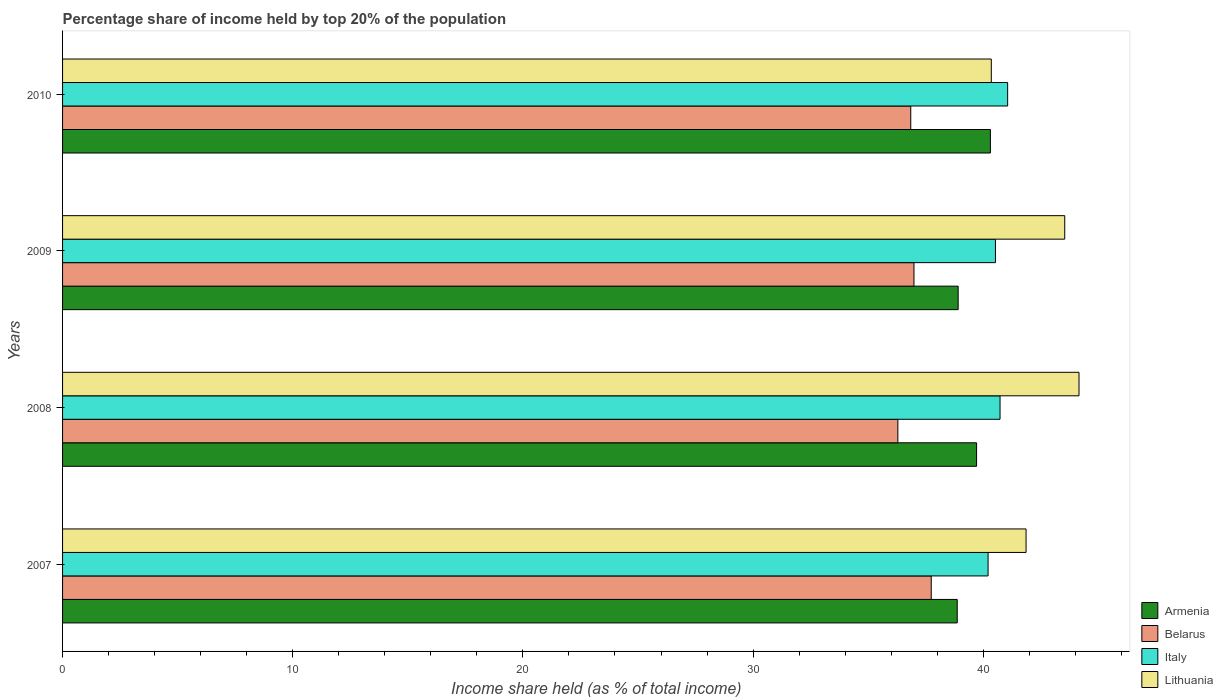Are the number of bars per tick equal to the number of legend labels?
Your answer should be very brief. Yes. Are the number of bars on each tick of the Y-axis equal?
Keep it short and to the point. Yes. How many bars are there on the 1st tick from the top?
Offer a very short reply. 4. What is the label of the 4th group of bars from the top?
Ensure brevity in your answer.  2007. In how many cases, is the number of bars for a given year not equal to the number of legend labels?
Make the answer very short. 0. What is the percentage share of income held by top 20% of the population in Lithuania in 2008?
Your answer should be very brief. 44.16. Across all years, what is the maximum percentage share of income held by top 20% of the population in Italy?
Your response must be concise. 41.06. Across all years, what is the minimum percentage share of income held by top 20% of the population in Armenia?
Keep it short and to the point. 38.87. In which year was the percentage share of income held by top 20% of the population in Italy minimum?
Offer a terse response. 2007. What is the total percentage share of income held by top 20% of the population in Lithuania in the graph?
Your response must be concise. 169.91. What is the difference between the percentage share of income held by top 20% of the population in Armenia in 2009 and that in 2010?
Your answer should be very brief. -1.4. What is the difference between the percentage share of income held by top 20% of the population in Italy in 2010 and the percentage share of income held by top 20% of the population in Armenia in 2008?
Your answer should be very brief. 1.35. What is the average percentage share of income held by top 20% of the population in Belarus per year?
Make the answer very short. 36.97. In the year 2007, what is the difference between the percentage share of income held by top 20% of the population in Belarus and percentage share of income held by top 20% of the population in Lithuania?
Your response must be concise. -4.12. In how many years, is the percentage share of income held by top 20% of the population in Belarus greater than 22 %?
Offer a very short reply. 4. What is the ratio of the percentage share of income held by top 20% of the population in Belarus in 2007 to that in 2008?
Your response must be concise. 1.04. Is the percentage share of income held by top 20% of the population in Lithuania in 2007 less than that in 2009?
Offer a very short reply. Yes. What is the difference between the highest and the second highest percentage share of income held by top 20% of the population in Italy?
Offer a very short reply. 0.33. What is the difference between the highest and the lowest percentage share of income held by top 20% of the population in Belarus?
Your response must be concise. 1.45. Is the sum of the percentage share of income held by top 20% of the population in Lithuania in 2008 and 2009 greater than the maximum percentage share of income held by top 20% of the population in Belarus across all years?
Make the answer very short. Yes. Is it the case that in every year, the sum of the percentage share of income held by top 20% of the population in Armenia and percentage share of income held by top 20% of the population in Belarus is greater than the sum of percentage share of income held by top 20% of the population in Lithuania and percentage share of income held by top 20% of the population in Italy?
Your answer should be very brief. No. What does the 3rd bar from the bottom in 2008 represents?
Provide a short and direct response. Italy. Is it the case that in every year, the sum of the percentage share of income held by top 20% of the population in Armenia and percentage share of income held by top 20% of the population in Belarus is greater than the percentage share of income held by top 20% of the population in Lithuania?
Provide a short and direct response. Yes. How many bars are there?
Your response must be concise. 16. Are all the bars in the graph horizontal?
Keep it short and to the point. Yes. Are the values on the major ticks of X-axis written in scientific E-notation?
Offer a terse response. No. Does the graph contain any zero values?
Provide a succinct answer. No. How are the legend labels stacked?
Offer a terse response. Vertical. What is the title of the graph?
Provide a short and direct response. Percentage share of income held by top 20% of the population. Does "Panama" appear as one of the legend labels in the graph?
Keep it short and to the point. No. What is the label or title of the X-axis?
Offer a very short reply. Income share held (as % of total income). What is the label or title of the Y-axis?
Ensure brevity in your answer.  Years. What is the Income share held (as % of total income) of Armenia in 2007?
Make the answer very short. 38.87. What is the Income share held (as % of total income) of Belarus in 2007?
Make the answer very short. 37.74. What is the Income share held (as % of total income) in Italy in 2007?
Keep it short and to the point. 40.21. What is the Income share held (as % of total income) of Lithuania in 2007?
Provide a succinct answer. 41.86. What is the Income share held (as % of total income) of Armenia in 2008?
Your answer should be compact. 39.71. What is the Income share held (as % of total income) of Belarus in 2008?
Ensure brevity in your answer.  36.29. What is the Income share held (as % of total income) of Italy in 2008?
Ensure brevity in your answer.  40.73. What is the Income share held (as % of total income) in Lithuania in 2008?
Provide a succinct answer. 44.16. What is the Income share held (as % of total income) of Armenia in 2009?
Keep it short and to the point. 38.91. What is the Income share held (as % of total income) of Belarus in 2009?
Offer a terse response. 36.99. What is the Income share held (as % of total income) of Italy in 2009?
Offer a terse response. 40.53. What is the Income share held (as % of total income) in Lithuania in 2009?
Provide a succinct answer. 43.54. What is the Income share held (as % of total income) in Armenia in 2010?
Your answer should be very brief. 40.31. What is the Income share held (as % of total income) in Belarus in 2010?
Your response must be concise. 36.85. What is the Income share held (as % of total income) in Italy in 2010?
Keep it short and to the point. 41.06. What is the Income share held (as % of total income) in Lithuania in 2010?
Ensure brevity in your answer.  40.35. Across all years, what is the maximum Income share held (as % of total income) in Armenia?
Provide a short and direct response. 40.31. Across all years, what is the maximum Income share held (as % of total income) of Belarus?
Offer a very short reply. 37.74. Across all years, what is the maximum Income share held (as % of total income) of Italy?
Keep it short and to the point. 41.06. Across all years, what is the maximum Income share held (as % of total income) of Lithuania?
Keep it short and to the point. 44.16. Across all years, what is the minimum Income share held (as % of total income) in Armenia?
Keep it short and to the point. 38.87. Across all years, what is the minimum Income share held (as % of total income) of Belarus?
Your answer should be very brief. 36.29. Across all years, what is the minimum Income share held (as % of total income) in Italy?
Provide a succinct answer. 40.21. Across all years, what is the minimum Income share held (as % of total income) in Lithuania?
Your answer should be very brief. 40.35. What is the total Income share held (as % of total income) of Armenia in the graph?
Provide a succinct answer. 157.8. What is the total Income share held (as % of total income) of Belarus in the graph?
Ensure brevity in your answer.  147.87. What is the total Income share held (as % of total income) of Italy in the graph?
Make the answer very short. 162.53. What is the total Income share held (as % of total income) of Lithuania in the graph?
Ensure brevity in your answer.  169.91. What is the difference between the Income share held (as % of total income) of Armenia in 2007 and that in 2008?
Ensure brevity in your answer.  -0.84. What is the difference between the Income share held (as % of total income) in Belarus in 2007 and that in 2008?
Provide a short and direct response. 1.45. What is the difference between the Income share held (as % of total income) of Italy in 2007 and that in 2008?
Offer a very short reply. -0.52. What is the difference between the Income share held (as % of total income) of Lithuania in 2007 and that in 2008?
Keep it short and to the point. -2.3. What is the difference between the Income share held (as % of total income) of Armenia in 2007 and that in 2009?
Your answer should be very brief. -0.04. What is the difference between the Income share held (as % of total income) of Belarus in 2007 and that in 2009?
Your answer should be compact. 0.75. What is the difference between the Income share held (as % of total income) in Italy in 2007 and that in 2009?
Your response must be concise. -0.32. What is the difference between the Income share held (as % of total income) of Lithuania in 2007 and that in 2009?
Offer a terse response. -1.68. What is the difference between the Income share held (as % of total income) in Armenia in 2007 and that in 2010?
Your answer should be very brief. -1.44. What is the difference between the Income share held (as % of total income) in Belarus in 2007 and that in 2010?
Your answer should be very brief. 0.89. What is the difference between the Income share held (as % of total income) of Italy in 2007 and that in 2010?
Make the answer very short. -0.85. What is the difference between the Income share held (as % of total income) of Lithuania in 2007 and that in 2010?
Your answer should be compact. 1.51. What is the difference between the Income share held (as % of total income) in Armenia in 2008 and that in 2009?
Provide a succinct answer. 0.8. What is the difference between the Income share held (as % of total income) of Italy in 2008 and that in 2009?
Your answer should be compact. 0.2. What is the difference between the Income share held (as % of total income) of Lithuania in 2008 and that in 2009?
Keep it short and to the point. 0.62. What is the difference between the Income share held (as % of total income) in Armenia in 2008 and that in 2010?
Provide a succinct answer. -0.6. What is the difference between the Income share held (as % of total income) of Belarus in 2008 and that in 2010?
Offer a terse response. -0.56. What is the difference between the Income share held (as % of total income) in Italy in 2008 and that in 2010?
Your answer should be compact. -0.33. What is the difference between the Income share held (as % of total income) in Lithuania in 2008 and that in 2010?
Ensure brevity in your answer.  3.81. What is the difference between the Income share held (as % of total income) in Belarus in 2009 and that in 2010?
Offer a very short reply. 0.14. What is the difference between the Income share held (as % of total income) in Italy in 2009 and that in 2010?
Make the answer very short. -0.53. What is the difference between the Income share held (as % of total income) in Lithuania in 2009 and that in 2010?
Give a very brief answer. 3.19. What is the difference between the Income share held (as % of total income) of Armenia in 2007 and the Income share held (as % of total income) of Belarus in 2008?
Provide a short and direct response. 2.58. What is the difference between the Income share held (as % of total income) of Armenia in 2007 and the Income share held (as % of total income) of Italy in 2008?
Your answer should be compact. -1.86. What is the difference between the Income share held (as % of total income) of Armenia in 2007 and the Income share held (as % of total income) of Lithuania in 2008?
Give a very brief answer. -5.29. What is the difference between the Income share held (as % of total income) in Belarus in 2007 and the Income share held (as % of total income) in Italy in 2008?
Your response must be concise. -2.99. What is the difference between the Income share held (as % of total income) in Belarus in 2007 and the Income share held (as % of total income) in Lithuania in 2008?
Offer a terse response. -6.42. What is the difference between the Income share held (as % of total income) of Italy in 2007 and the Income share held (as % of total income) of Lithuania in 2008?
Ensure brevity in your answer.  -3.95. What is the difference between the Income share held (as % of total income) of Armenia in 2007 and the Income share held (as % of total income) of Belarus in 2009?
Provide a short and direct response. 1.88. What is the difference between the Income share held (as % of total income) in Armenia in 2007 and the Income share held (as % of total income) in Italy in 2009?
Provide a short and direct response. -1.66. What is the difference between the Income share held (as % of total income) in Armenia in 2007 and the Income share held (as % of total income) in Lithuania in 2009?
Your answer should be very brief. -4.67. What is the difference between the Income share held (as % of total income) in Belarus in 2007 and the Income share held (as % of total income) in Italy in 2009?
Keep it short and to the point. -2.79. What is the difference between the Income share held (as % of total income) in Italy in 2007 and the Income share held (as % of total income) in Lithuania in 2009?
Make the answer very short. -3.33. What is the difference between the Income share held (as % of total income) in Armenia in 2007 and the Income share held (as % of total income) in Belarus in 2010?
Your answer should be very brief. 2.02. What is the difference between the Income share held (as % of total income) of Armenia in 2007 and the Income share held (as % of total income) of Italy in 2010?
Give a very brief answer. -2.19. What is the difference between the Income share held (as % of total income) in Armenia in 2007 and the Income share held (as % of total income) in Lithuania in 2010?
Ensure brevity in your answer.  -1.48. What is the difference between the Income share held (as % of total income) in Belarus in 2007 and the Income share held (as % of total income) in Italy in 2010?
Give a very brief answer. -3.32. What is the difference between the Income share held (as % of total income) of Belarus in 2007 and the Income share held (as % of total income) of Lithuania in 2010?
Ensure brevity in your answer.  -2.61. What is the difference between the Income share held (as % of total income) in Italy in 2007 and the Income share held (as % of total income) in Lithuania in 2010?
Your response must be concise. -0.14. What is the difference between the Income share held (as % of total income) of Armenia in 2008 and the Income share held (as % of total income) of Belarus in 2009?
Provide a short and direct response. 2.72. What is the difference between the Income share held (as % of total income) of Armenia in 2008 and the Income share held (as % of total income) of Italy in 2009?
Make the answer very short. -0.82. What is the difference between the Income share held (as % of total income) of Armenia in 2008 and the Income share held (as % of total income) of Lithuania in 2009?
Provide a short and direct response. -3.83. What is the difference between the Income share held (as % of total income) of Belarus in 2008 and the Income share held (as % of total income) of Italy in 2009?
Make the answer very short. -4.24. What is the difference between the Income share held (as % of total income) in Belarus in 2008 and the Income share held (as % of total income) in Lithuania in 2009?
Give a very brief answer. -7.25. What is the difference between the Income share held (as % of total income) in Italy in 2008 and the Income share held (as % of total income) in Lithuania in 2009?
Ensure brevity in your answer.  -2.81. What is the difference between the Income share held (as % of total income) of Armenia in 2008 and the Income share held (as % of total income) of Belarus in 2010?
Give a very brief answer. 2.86. What is the difference between the Income share held (as % of total income) in Armenia in 2008 and the Income share held (as % of total income) in Italy in 2010?
Ensure brevity in your answer.  -1.35. What is the difference between the Income share held (as % of total income) of Armenia in 2008 and the Income share held (as % of total income) of Lithuania in 2010?
Keep it short and to the point. -0.64. What is the difference between the Income share held (as % of total income) in Belarus in 2008 and the Income share held (as % of total income) in Italy in 2010?
Keep it short and to the point. -4.77. What is the difference between the Income share held (as % of total income) of Belarus in 2008 and the Income share held (as % of total income) of Lithuania in 2010?
Keep it short and to the point. -4.06. What is the difference between the Income share held (as % of total income) of Italy in 2008 and the Income share held (as % of total income) of Lithuania in 2010?
Your answer should be very brief. 0.38. What is the difference between the Income share held (as % of total income) of Armenia in 2009 and the Income share held (as % of total income) of Belarus in 2010?
Your response must be concise. 2.06. What is the difference between the Income share held (as % of total income) of Armenia in 2009 and the Income share held (as % of total income) of Italy in 2010?
Make the answer very short. -2.15. What is the difference between the Income share held (as % of total income) in Armenia in 2009 and the Income share held (as % of total income) in Lithuania in 2010?
Your response must be concise. -1.44. What is the difference between the Income share held (as % of total income) of Belarus in 2009 and the Income share held (as % of total income) of Italy in 2010?
Provide a succinct answer. -4.07. What is the difference between the Income share held (as % of total income) of Belarus in 2009 and the Income share held (as % of total income) of Lithuania in 2010?
Your answer should be compact. -3.36. What is the difference between the Income share held (as % of total income) of Italy in 2009 and the Income share held (as % of total income) of Lithuania in 2010?
Keep it short and to the point. 0.18. What is the average Income share held (as % of total income) in Armenia per year?
Offer a terse response. 39.45. What is the average Income share held (as % of total income) of Belarus per year?
Give a very brief answer. 36.97. What is the average Income share held (as % of total income) of Italy per year?
Offer a very short reply. 40.63. What is the average Income share held (as % of total income) in Lithuania per year?
Make the answer very short. 42.48. In the year 2007, what is the difference between the Income share held (as % of total income) in Armenia and Income share held (as % of total income) in Belarus?
Your answer should be very brief. 1.13. In the year 2007, what is the difference between the Income share held (as % of total income) in Armenia and Income share held (as % of total income) in Italy?
Your answer should be very brief. -1.34. In the year 2007, what is the difference between the Income share held (as % of total income) in Armenia and Income share held (as % of total income) in Lithuania?
Offer a very short reply. -2.99. In the year 2007, what is the difference between the Income share held (as % of total income) in Belarus and Income share held (as % of total income) in Italy?
Provide a short and direct response. -2.47. In the year 2007, what is the difference between the Income share held (as % of total income) in Belarus and Income share held (as % of total income) in Lithuania?
Provide a succinct answer. -4.12. In the year 2007, what is the difference between the Income share held (as % of total income) in Italy and Income share held (as % of total income) in Lithuania?
Your answer should be very brief. -1.65. In the year 2008, what is the difference between the Income share held (as % of total income) in Armenia and Income share held (as % of total income) in Belarus?
Make the answer very short. 3.42. In the year 2008, what is the difference between the Income share held (as % of total income) in Armenia and Income share held (as % of total income) in Italy?
Your response must be concise. -1.02. In the year 2008, what is the difference between the Income share held (as % of total income) of Armenia and Income share held (as % of total income) of Lithuania?
Keep it short and to the point. -4.45. In the year 2008, what is the difference between the Income share held (as % of total income) of Belarus and Income share held (as % of total income) of Italy?
Your response must be concise. -4.44. In the year 2008, what is the difference between the Income share held (as % of total income) of Belarus and Income share held (as % of total income) of Lithuania?
Your answer should be compact. -7.87. In the year 2008, what is the difference between the Income share held (as % of total income) of Italy and Income share held (as % of total income) of Lithuania?
Provide a short and direct response. -3.43. In the year 2009, what is the difference between the Income share held (as % of total income) of Armenia and Income share held (as % of total income) of Belarus?
Ensure brevity in your answer.  1.92. In the year 2009, what is the difference between the Income share held (as % of total income) in Armenia and Income share held (as % of total income) in Italy?
Offer a terse response. -1.62. In the year 2009, what is the difference between the Income share held (as % of total income) in Armenia and Income share held (as % of total income) in Lithuania?
Your response must be concise. -4.63. In the year 2009, what is the difference between the Income share held (as % of total income) in Belarus and Income share held (as % of total income) in Italy?
Give a very brief answer. -3.54. In the year 2009, what is the difference between the Income share held (as % of total income) in Belarus and Income share held (as % of total income) in Lithuania?
Give a very brief answer. -6.55. In the year 2009, what is the difference between the Income share held (as % of total income) of Italy and Income share held (as % of total income) of Lithuania?
Provide a succinct answer. -3.01. In the year 2010, what is the difference between the Income share held (as % of total income) in Armenia and Income share held (as % of total income) in Belarus?
Make the answer very short. 3.46. In the year 2010, what is the difference between the Income share held (as % of total income) in Armenia and Income share held (as % of total income) in Italy?
Provide a succinct answer. -0.75. In the year 2010, what is the difference between the Income share held (as % of total income) of Armenia and Income share held (as % of total income) of Lithuania?
Your answer should be compact. -0.04. In the year 2010, what is the difference between the Income share held (as % of total income) of Belarus and Income share held (as % of total income) of Italy?
Give a very brief answer. -4.21. In the year 2010, what is the difference between the Income share held (as % of total income) in Belarus and Income share held (as % of total income) in Lithuania?
Give a very brief answer. -3.5. In the year 2010, what is the difference between the Income share held (as % of total income) in Italy and Income share held (as % of total income) in Lithuania?
Keep it short and to the point. 0.71. What is the ratio of the Income share held (as % of total income) of Armenia in 2007 to that in 2008?
Provide a succinct answer. 0.98. What is the ratio of the Income share held (as % of total income) of Belarus in 2007 to that in 2008?
Provide a succinct answer. 1.04. What is the ratio of the Income share held (as % of total income) of Italy in 2007 to that in 2008?
Provide a succinct answer. 0.99. What is the ratio of the Income share held (as % of total income) in Lithuania in 2007 to that in 2008?
Ensure brevity in your answer.  0.95. What is the ratio of the Income share held (as % of total income) in Armenia in 2007 to that in 2009?
Provide a succinct answer. 1. What is the ratio of the Income share held (as % of total income) of Belarus in 2007 to that in 2009?
Offer a terse response. 1.02. What is the ratio of the Income share held (as % of total income) of Lithuania in 2007 to that in 2009?
Offer a very short reply. 0.96. What is the ratio of the Income share held (as % of total income) in Belarus in 2007 to that in 2010?
Offer a terse response. 1.02. What is the ratio of the Income share held (as % of total income) of Italy in 2007 to that in 2010?
Give a very brief answer. 0.98. What is the ratio of the Income share held (as % of total income) in Lithuania in 2007 to that in 2010?
Offer a terse response. 1.04. What is the ratio of the Income share held (as % of total income) in Armenia in 2008 to that in 2009?
Give a very brief answer. 1.02. What is the ratio of the Income share held (as % of total income) in Belarus in 2008 to that in 2009?
Give a very brief answer. 0.98. What is the ratio of the Income share held (as % of total income) of Lithuania in 2008 to that in 2009?
Provide a short and direct response. 1.01. What is the ratio of the Income share held (as % of total income) in Armenia in 2008 to that in 2010?
Make the answer very short. 0.99. What is the ratio of the Income share held (as % of total income) in Italy in 2008 to that in 2010?
Provide a succinct answer. 0.99. What is the ratio of the Income share held (as % of total income) in Lithuania in 2008 to that in 2010?
Make the answer very short. 1.09. What is the ratio of the Income share held (as % of total income) in Armenia in 2009 to that in 2010?
Offer a terse response. 0.97. What is the ratio of the Income share held (as % of total income) in Belarus in 2009 to that in 2010?
Offer a very short reply. 1. What is the ratio of the Income share held (as % of total income) of Italy in 2009 to that in 2010?
Ensure brevity in your answer.  0.99. What is the ratio of the Income share held (as % of total income) in Lithuania in 2009 to that in 2010?
Your response must be concise. 1.08. What is the difference between the highest and the second highest Income share held (as % of total income) in Armenia?
Make the answer very short. 0.6. What is the difference between the highest and the second highest Income share held (as % of total income) in Belarus?
Make the answer very short. 0.75. What is the difference between the highest and the second highest Income share held (as % of total income) of Italy?
Provide a short and direct response. 0.33. What is the difference between the highest and the second highest Income share held (as % of total income) of Lithuania?
Make the answer very short. 0.62. What is the difference between the highest and the lowest Income share held (as % of total income) of Armenia?
Provide a succinct answer. 1.44. What is the difference between the highest and the lowest Income share held (as % of total income) of Belarus?
Your answer should be compact. 1.45. What is the difference between the highest and the lowest Income share held (as % of total income) of Italy?
Provide a succinct answer. 0.85. What is the difference between the highest and the lowest Income share held (as % of total income) in Lithuania?
Your response must be concise. 3.81. 